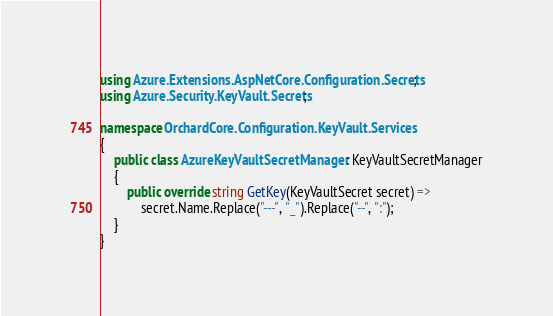Convert code to text. <code><loc_0><loc_0><loc_500><loc_500><_C#_>using Azure.Extensions.AspNetCore.Configuration.Secrets;
using Azure.Security.KeyVault.Secrets;

namespace OrchardCore.Configuration.KeyVault.Services
{
    public class AzureKeyVaultSecretManager : KeyVaultSecretManager
    {
        public override string GetKey(KeyVaultSecret secret) =>
            secret.Name.Replace("---", "_").Replace("--", ":");
    }
}
</code> 